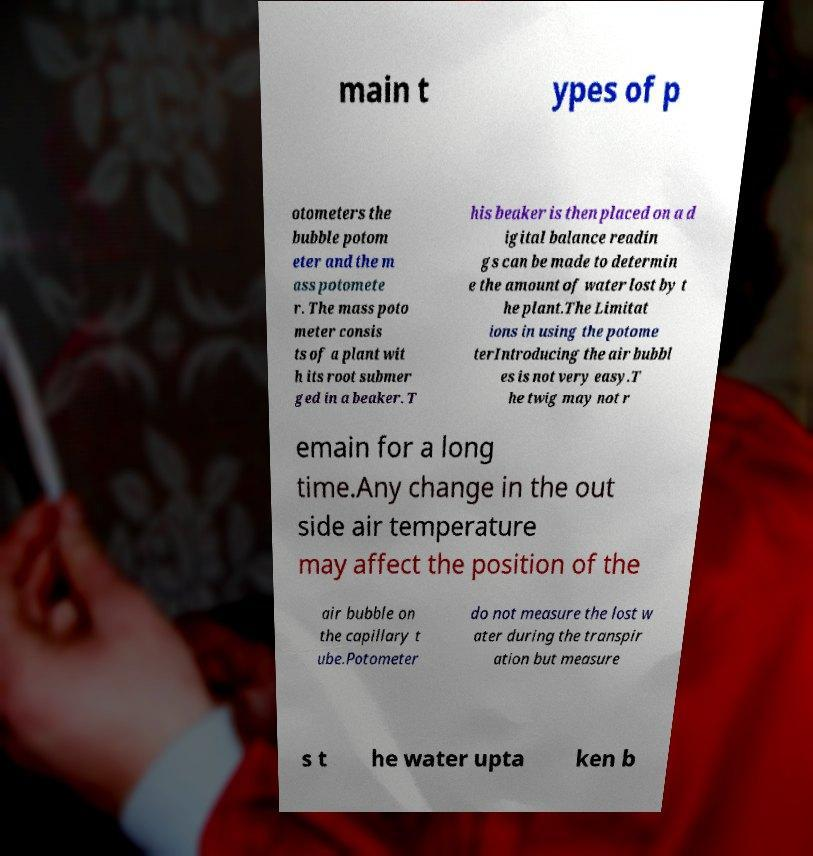Could you assist in decoding the text presented in this image and type it out clearly? main t ypes of p otometers the bubble potom eter and the m ass potomete r. The mass poto meter consis ts of a plant wit h its root submer ged in a beaker. T his beaker is then placed on a d igital balance readin gs can be made to determin e the amount of water lost by t he plant.The Limitat ions in using the potome terIntroducing the air bubbl es is not very easy.T he twig may not r emain for a long time.Any change in the out side air temperature may affect the position of the air bubble on the capillary t ube.Potometer do not measure the lost w ater during the transpir ation but measure s t he water upta ken b 